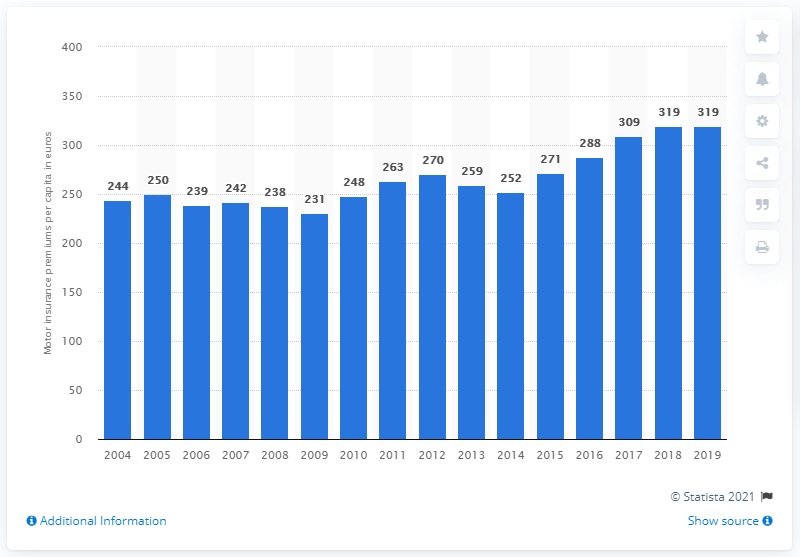What trend is shown in the graph from the years 2004 to 2019? The graph shows a general upward trend in the average premium per capita from 2004 to 2019, with some fluctuations. While there are noticeable increases some years, other years display a more stable or slight increase. 